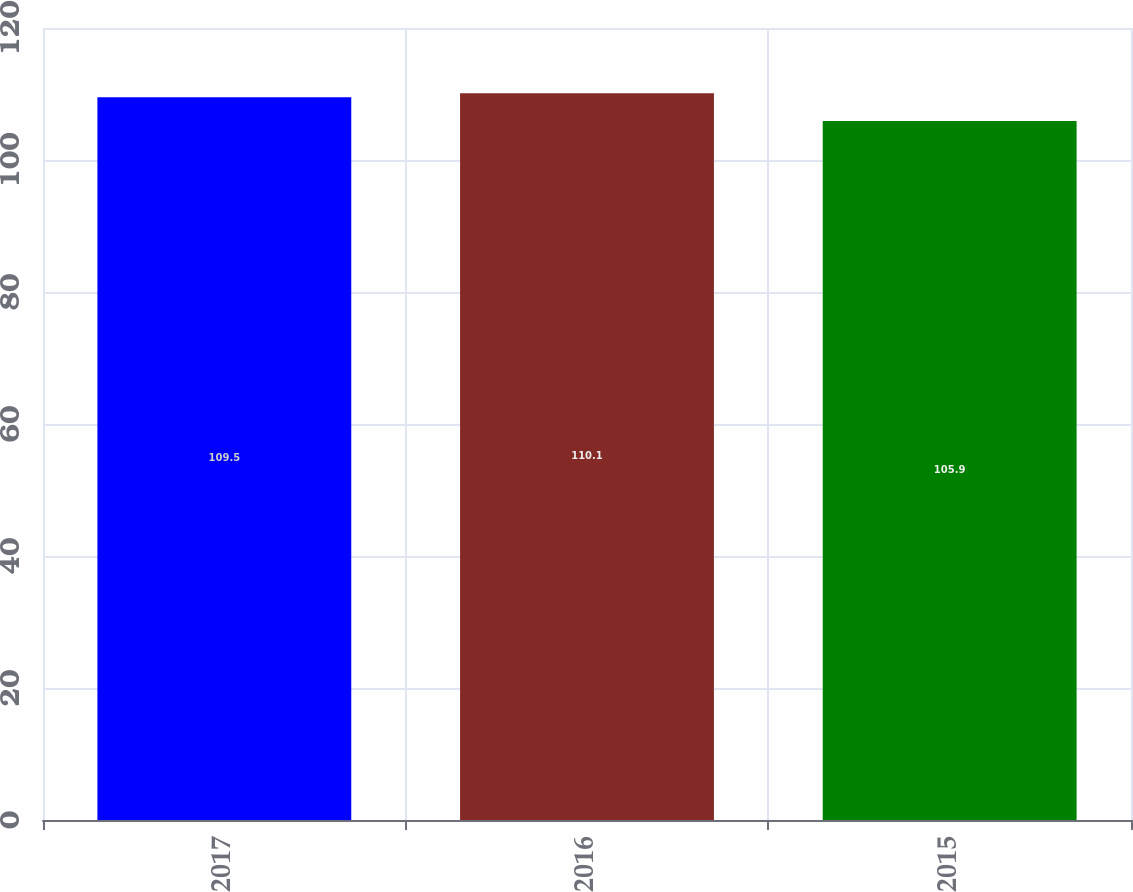Convert chart. <chart><loc_0><loc_0><loc_500><loc_500><bar_chart><fcel>2017<fcel>2016<fcel>2015<nl><fcel>109.5<fcel>110.1<fcel>105.9<nl></chart> 